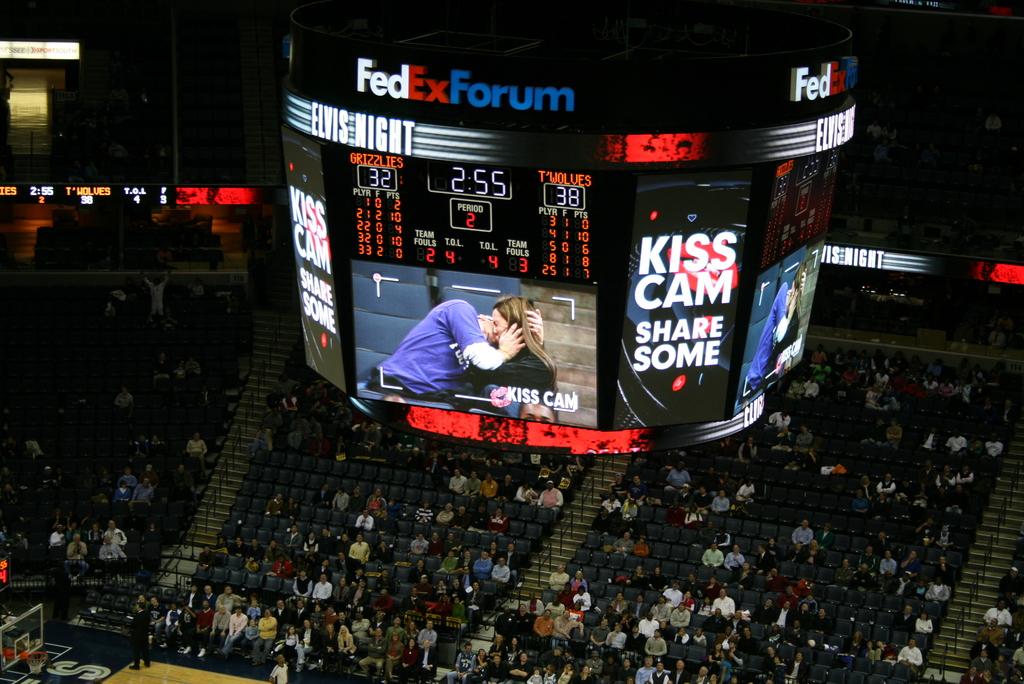What is the camera showing?
Your answer should be very brief. Kiss cam. Which team is winning?
Offer a very short reply. T'wolves. 